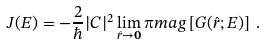<formula> <loc_0><loc_0><loc_500><loc_500>J ( E ) = - \frac { 2 } { \hbar } { | } C | ^ { 2 } \lim _ { \hat { r } \rightarrow \mathbf 0 } \i m a g \left [ G ( \hat { r } ; E ) \right ] \, .</formula> 